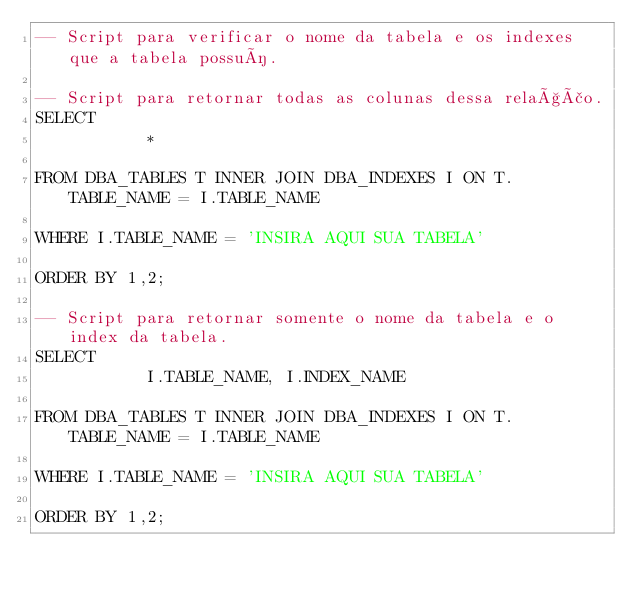Convert code to text. <code><loc_0><loc_0><loc_500><loc_500><_SQL_>-- Script para verificar o nome da tabela e os indexes que a tabela possuí.

-- Script para retornar todas as colunas dessa relação.
SELECT 
           *
           
FROM DBA_TABLES T INNER JOIN DBA_INDEXES I ON T.TABLE_NAME = I.TABLE_NAME

WHERE I.TABLE_NAME = 'INSIRA AQUI SUA TABELA'

ORDER BY 1,2;

-- Script para retornar somente o nome da tabela e o index da tabela.
SELECT 
           I.TABLE_NAME, I.INDEX_NAME
           
FROM DBA_TABLES T INNER JOIN DBA_INDEXES I ON T.TABLE_NAME = I.TABLE_NAME

WHERE I.TABLE_NAME = 'INSIRA AQUI SUA TABELA'

ORDER BY 1,2;</code> 